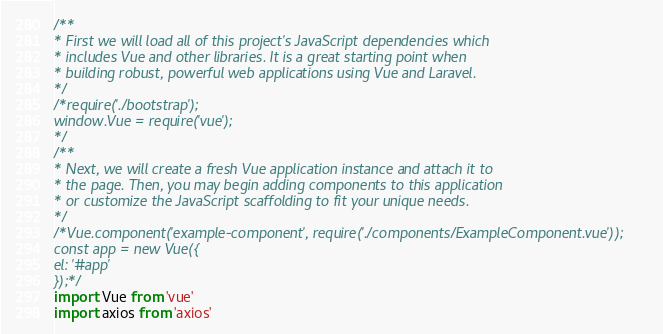Convert code to text. <code><loc_0><loc_0><loc_500><loc_500><_JavaScript_>/**
* First we will load all of this project's JavaScript dependencies which
* includes Vue and other libraries. It is a great starting point when
* building robust, powerful web applications using Vue and Laravel.
*/
/*require('./bootstrap');
window.Vue = require('vue');
*/
/**
* Next, we will create a fresh Vue application instance and attach it to
* the page. Then, you may begin adding components to this application
* or customize the JavaScript scaffolding to fit your unique needs.
*/
/*Vue.component('example-component', require('./components/ExampleComponent.vue'));
const app = new Vue({
el: '#app'
});*/
import Vue from 'vue'
import axios from 'axios'</code> 